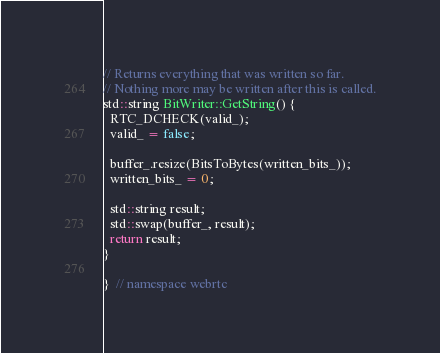<code> <loc_0><loc_0><loc_500><loc_500><_C++_>
// Returns everything that was written so far.
// Nothing more may be written after this is called.
std::string BitWriter::GetString() {
  RTC_DCHECK(valid_);
  valid_ = false;

  buffer_.resize(BitsToBytes(written_bits_));
  written_bits_ = 0;

  std::string result;
  std::swap(buffer_, result);
  return result;
}

}  // namespace webrtc
</code> 